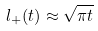Convert formula to latex. <formula><loc_0><loc_0><loc_500><loc_500>l _ { + } ( t ) \approx \sqrt { \pi t }</formula> 